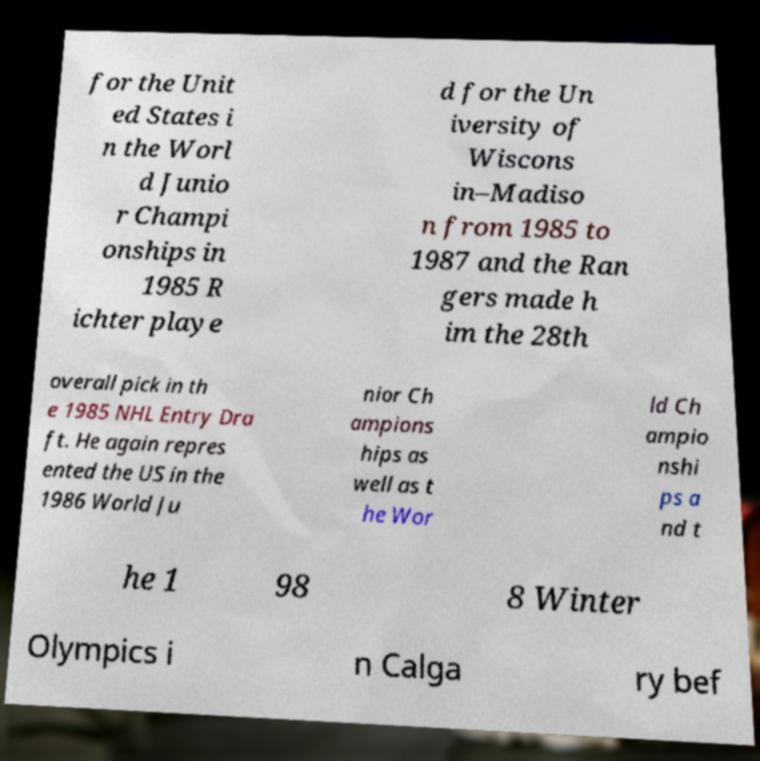Can you accurately transcribe the text from the provided image for me? for the Unit ed States i n the Worl d Junio r Champi onships in 1985 R ichter playe d for the Un iversity of Wiscons in–Madiso n from 1985 to 1987 and the Ran gers made h im the 28th overall pick in th e 1985 NHL Entry Dra ft. He again repres ented the US in the 1986 World Ju nior Ch ampions hips as well as t he Wor ld Ch ampio nshi ps a nd t he 1 98 8 Winter Olympics i n Calga ry bef 